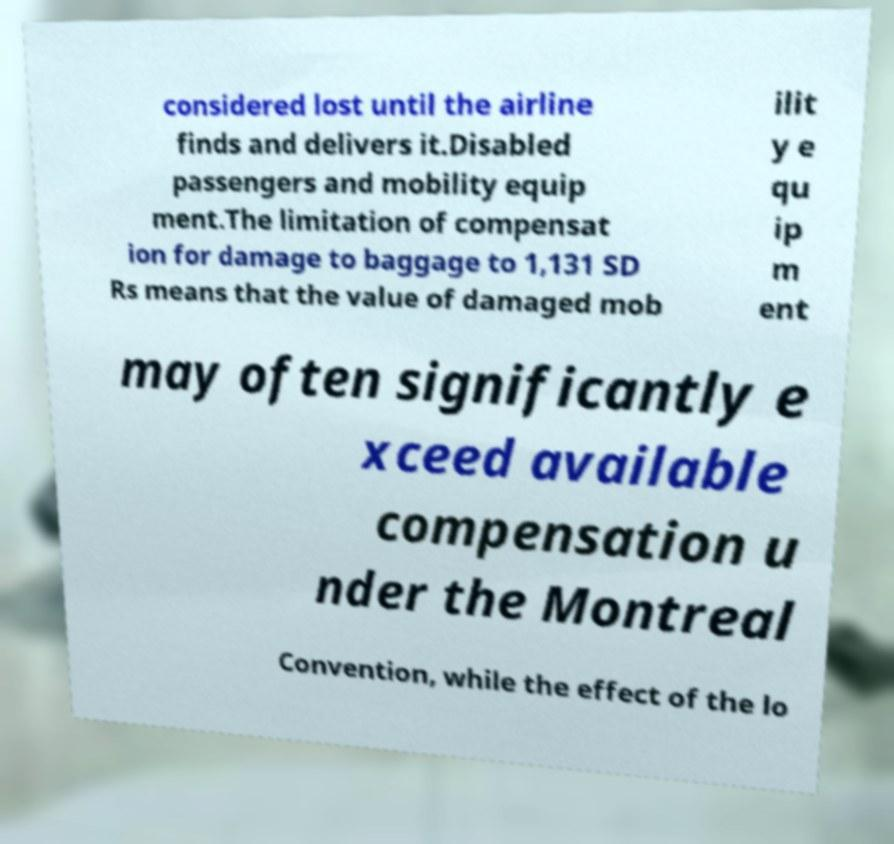Could you extract and type out the text from this image? considered lost until the airline finds and delivers it.Disabled passengers and mobility equip ment.The limitation of compensat ion for damage to baggage to 1,131 SD Rs means that the value of damaged mob ilit y e qu ip m ent may often significantly e xceed available compensation u nder the Montreal Convention, while the effect of the lo 